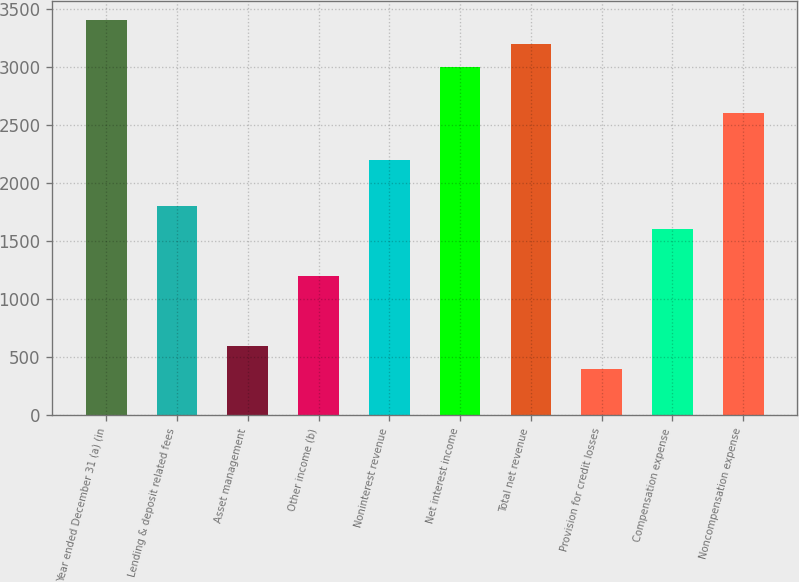Convert chart. <chart><loc_0><loc_0><loc_500><loc_500><bar_chart><fcel>Year ended December 31 (a) (in<fcel>Lending & deposit related fees<fcel>Asset management<fcel>Other income (b)<fcel>Noninterest revenue<fcel>Net interest income<fcel>Total net revenue<fcel>Provision for credit losses<fcel>Compensation expense<fcel>Noncompensation expense<nl><fcel>3403.74<fcel>1802.86<fcel>602.2<fcel>1202.53<fcel>2203.08<fcel>3003.52<fcel>3203.63<fcel>402.09<fcel>1602.75<fcel>2603.3<nl></chart> 